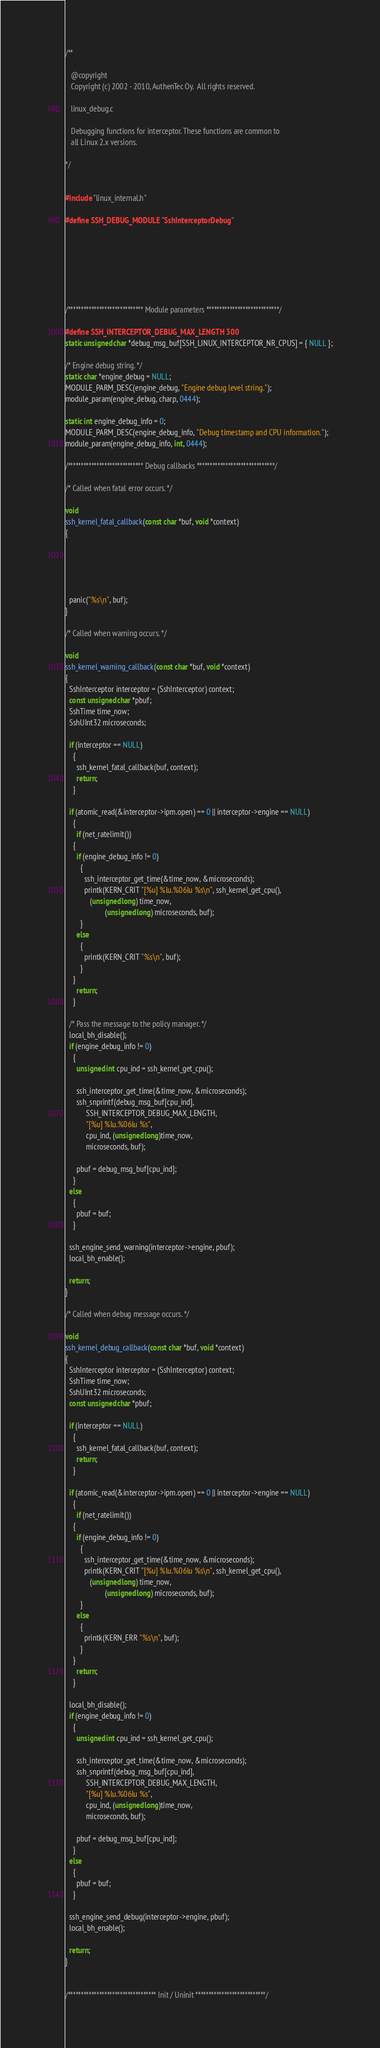Convert code to text. <code><loc_0><loc_0><loc_500><loc_500><_C_>/**
   
   @copyright
   Copyright (c) 2002 - 2010, AuthenTec Oy.  All rights reserved.
   
   linux_debug.c
   
   Debugging functions for interceptor. These functions are common to
   all Linux 2.x versions.
   
*/


#include "linux_internal.h"

#define SSH_DEBUG_MODULE "SshInterceptorDebug"







/***************************** Module parameters ****************************/

#define SSH_INTERCEPTOR_DEBUG_MAX_LENGTH 300
static unsigned char *debug_msg_buf[SSH_LINUX_INTERCEPTOR_NR_CPUS] = { NULL };

/* Engine debug string. */
static char *engine_debug = NULL;
MODULE_PARM_DESC(engine_debug, "Engine debug level string.");
module_param(engine_debug, charp, 0444);

static int engine_debug_info = 0;
MODULE_PARM_DESC(engine_debug_info, "Debug timestamp and CPU information.");
module_param(engine_debug_info, int, 0444);

/***************************** Debug callbacks ******************************/

/* Called when fatal error occurs. */

void
ssh_kernel_fatal_callback(const char *buf, void *context)
{





  panic("%s\n", buf);
}

/* Called when warning occurs. */

void
ssh_kernel_warning_callback(const char *buf, void *context)
{
  SshInterceptor interceptor = (SshInterceptor) context;
  const unsigned char *pbuf;
  SshTime time_now;
  SshUInt32 microseconds;

  if (interceptor == NULL)
    {
      ssh_kernel_fatal_callback(buf, context);
      return;
    }

  if (atomic_read(&interceptor->ipm.open) == 0 || interceptor->engine == NULL)
    {
      if (net_ratelimit())
	{
	  if (engine_debug_info != 0)
	    {
	      ssh_interceptor_get_time(&time_now, &microseconds);
	      printk(KERN_CRIT "[%u] %lu.%06lu %s\n", ssh_kernel_get_cpu(), 
		     (unsigned long) time_now, 
                     (unsigned long) microseconds, buf);
	    }
	  else
	    {
	      printk(KERN_CRIT "%s\n", buf);
	    }
	}
      return;
    }

  /* Pass the message to the policy manager. */
  local_bh_disable();
  if (engine_debug_info != 0)
    {
      unsigned int cpu_ind = ssh_kernel_get_cpu();

      ssh_interceptor_get_time(&time_now, &microseconds);
      ssh_snprintf(debug_msg_buf[cpu_ind], 
		   SSH_INTERCEPTOR_DEBUG_MAX_LENGTH, 
		   "[%u] %lu.%06lu %s", 
		   cpu_ind, (unsigned long)time_now, 
		   microseconds, buf);

      pbuf = debug_msg_buf[cpu_ind];
    }
  else
    {
      pbuf = buf;
    }
  
  ssh_engine_send_warning(interceptor->engine, pbuf);
  local_bh_enable();

  return;
}

/* Called when debug message occurs. */

void
ssh_kernel_debug_callback(const char *buf, void *context)
{
  SshInterceptor interceptor = (SshInterceptor) context;
  SshTime time_now;
  SshUInt32 microseconds;
  const unsigned char *pbuf;

  if (interceptor == NULL)
    {
      ssh_kernel_fatal_callback(buf, context);
      return;
    }

  if (atomic_read(&interceptor->ipm.open) == 0 || interceptor->engine == NULL)
    {
      if (net_ratelimit())
	{
	  if (engine_debug_info != 0)
	    {
	      ssh_interceptor_get_time(&time_now, &microseconds);
	      printk(KERN_CRIT "[%u] %lu.%06lu %s\n", ssh_kernel_get_cpu(), 
		     (unsigned long) time_now, 
                     (unsigned long) microseconds, buf);
	    }
	  else
	    {
	      printk(KERN_ERR "%s\n", buf);
	    }
	}
      return;
    }

  local_bh_disable();
  if (engine_debug_info != 0)
    {
      unsigned int cpu_ind = ssh_kernel_get_cpu();

      ssh_interceptor_get_time(&time_now, &microseconds);
      ssh_snprintf(debug_msg_buf[cpu_ind], 
		   SSH_INTERCEPTOR_DEBUG_MAX_LENGTH, 
		   "[%u] %lu.%06lu %s", 
		   cpu_ind, (unsigned long)time_now, 
		   microseconds, buf);

      pbuf = debug_msg_buf[cpu_ind];
    }
  else
    {
      pbuf = buf;
    }
  
  ssh_engine_send_debug(interceptor->engine, pbuf);
  local_bh_enable();

  return;
}


/********************************** Init / Uninit ***************************/
</code> 